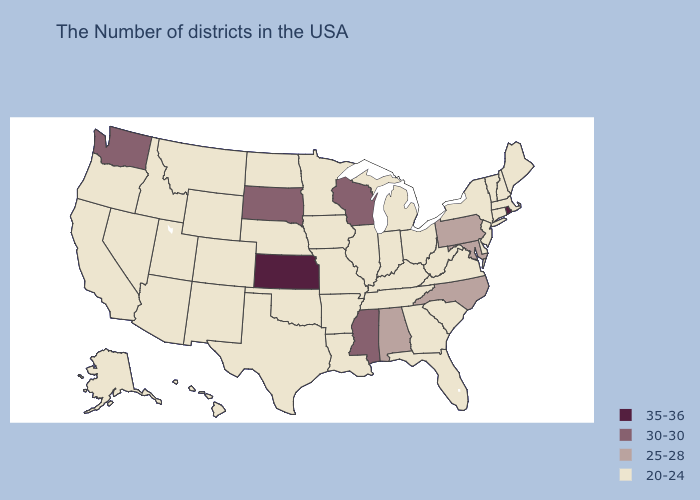What is the highest value in the Northeast ?
Short answer required. 35-36. What is the highest value in states that border Tennessee?
Concise answer only. 30-30. What is the value of Pennsylvania?
Quick response, please. 25-28. Name the states that have a value in the range 25-28?
Give a very brief answer. Maryland, Pennsylvania, North Carolina, Alabama. Is the legend a continuous bar?
Concise answer only. No. What is the lowest value in the USA?
Concise answer only. 20-24. Name the states that have a value in the range 20-24?
Write a very short answer. Maine, Massachusetts, New Hampshire, Vermont, Connecticut, New York, New Jersey, Delaware, Virginia, South Carolina, West Virginia, Ohio, Florida, Georgia, Michigan, Kentucky, Indiana, Tennessee, Illinois, Louisiana, Missouri, Arkansas, Minnesota, Iowa, Nebraska, Oklahoma, Texas, North Dakota, Wyoming, Colorado, New Mexico, Utah, Montana, Arizona, Idaho, Nevada, California, Oregon, Alaska, Hawaii. Among the states that border Maryland , does Pennsylvania have the highest value?
Quick response, please. Yes. Which states have the highest value in the USA?
Write a very short answer. Rhode Island, Kansas. What is the value of Louisiana?
Write a very short answer. 20-24. What is the value of Delaware?
Concise answer only. 20-24. Name the states that have a value in the range 25-28?
Short answer required. Maryland, Pennsylvania, North Carolina, Alabama. Does Florida have a higher value than Nebraska?
Write a very short answer. No. Name the states that have a value in the range 30-30?
Be succinct. Wisconsin, Mississippi, South Dakota, Washington. 